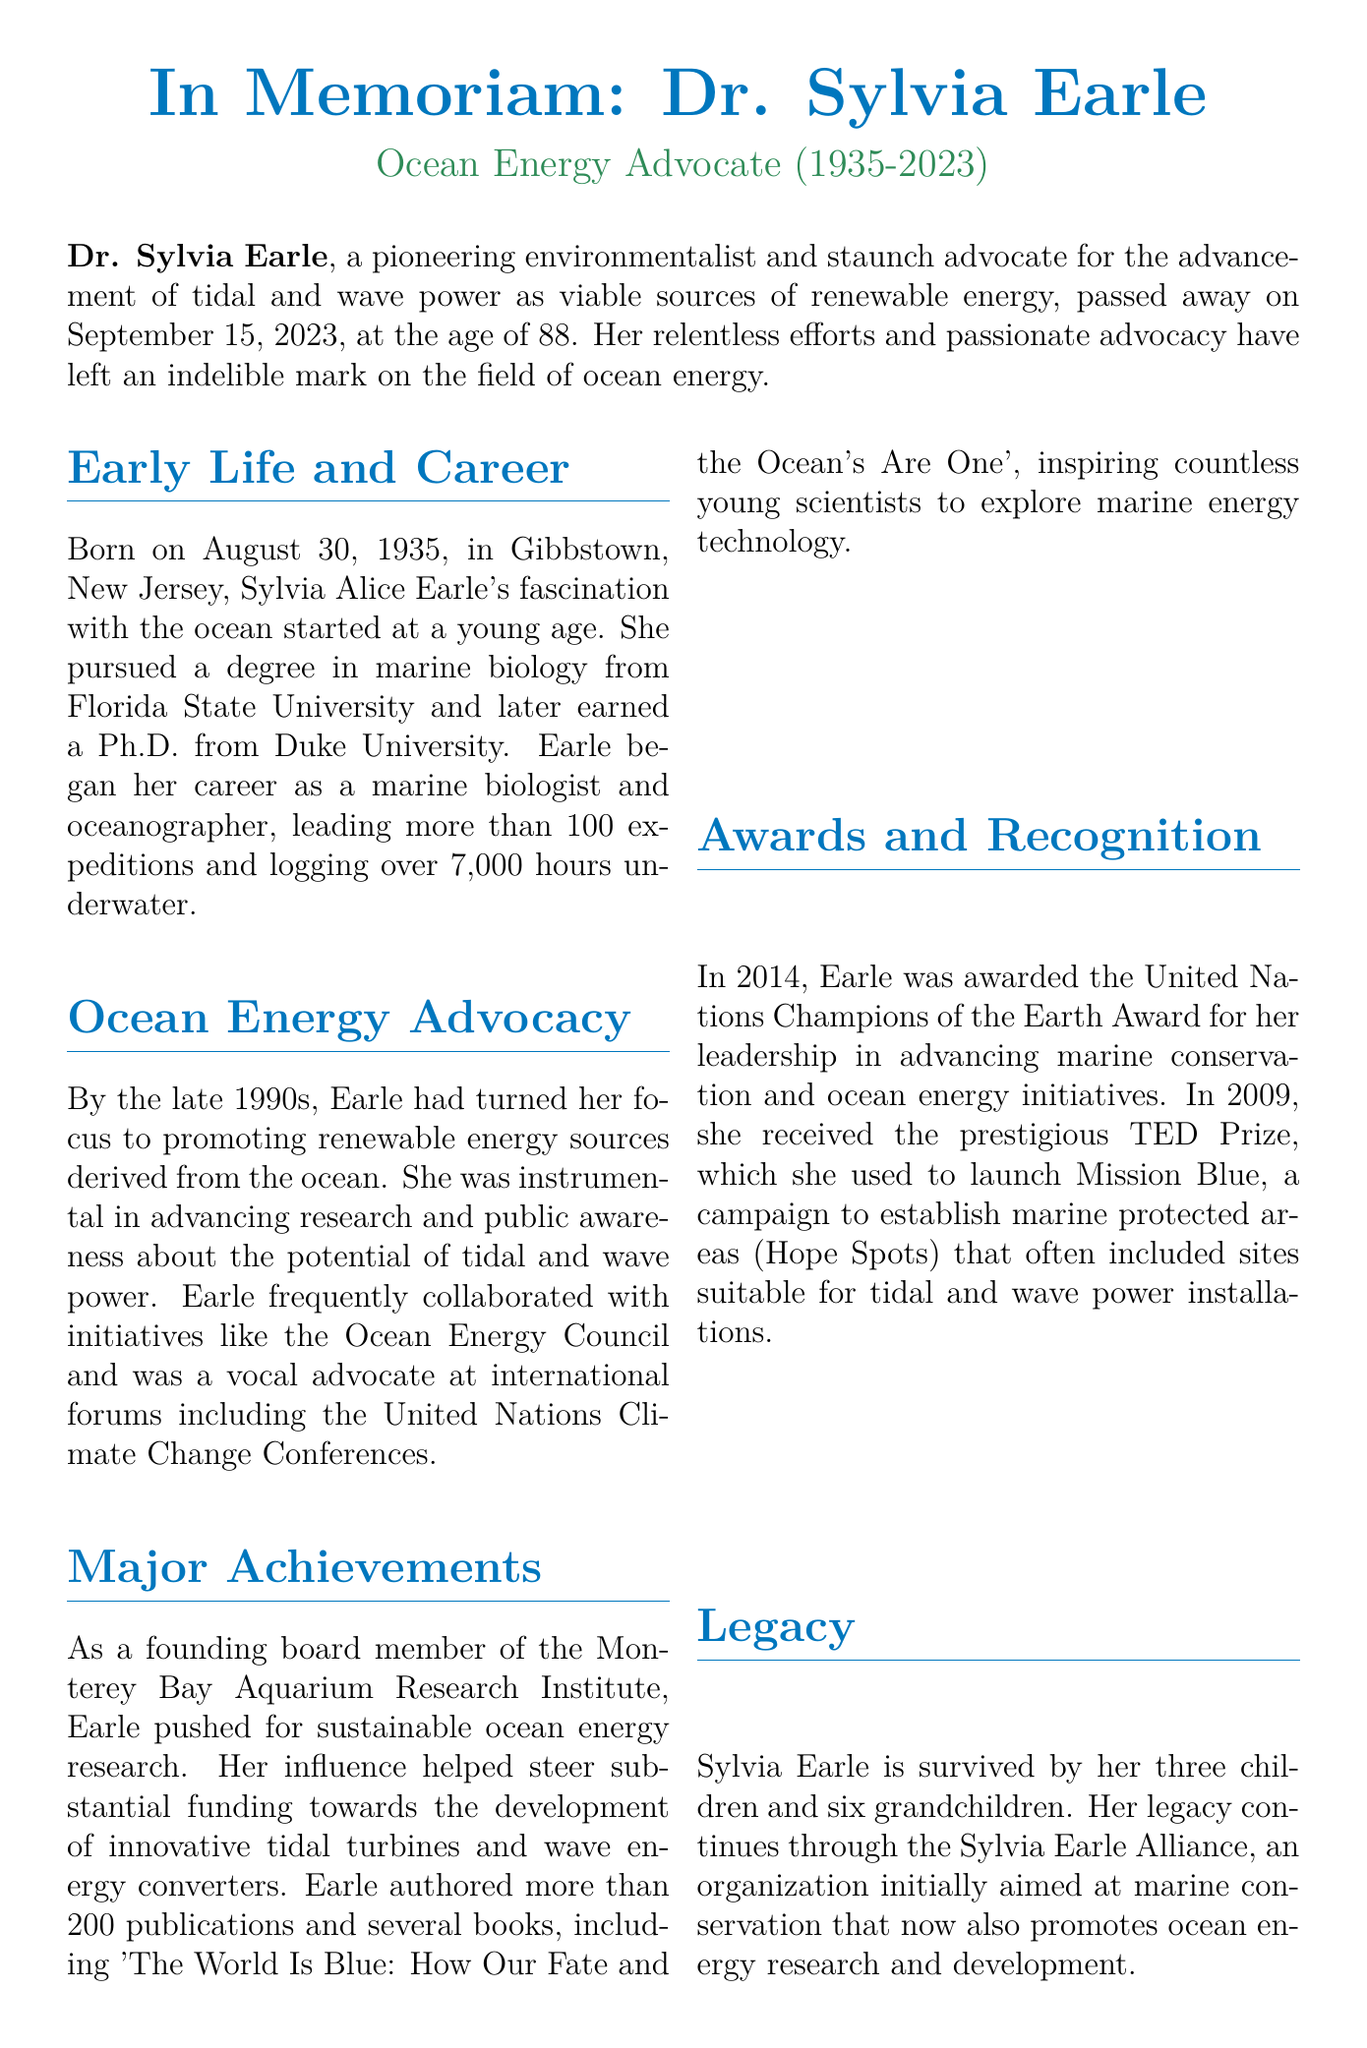what was the date of Dr. Sylvia Earle's passing? The document states that Dr. Sylvia Earle passed away on September 15, 2023.
Answer: September 15, 2023 how old was Dr. Earle at the time of her death? The document indicates that Dr. Earle was 88 years old when she passed away.
Answer: 88 which organization did Dr. Earle help to found? The document mentions that Dr. Earle was a founding board member of the Monterey Bay Aquarium Research Institute.
Answer: Monterey Bay Aquarium Research Institute what year did Dr. Earle receive the United Nations Champions of the Earth Award? The document notes that Dr. Earle received this award in 2014.
Answer: 2014 how many publications did Dr. Earle author? According to the document, Dr. Earle authored more than 200 publications.
Answer: more than 200 what was the mission of the campaign launched with the TED Prize? The document states that the campaign was to establish marine protected areas (Hope Spots).
Answer: marine protected areas (Hope Spots) what is the name of the organization that Dr. Earle's legacy continues through? The document mentions the Sylvia Earle Alliance as the organization continuing her legacy.
Answer: Sylvia Earle Alliance what was Dr. Earle's primary focus in the late 1990s? The document states that she turned her focus to promoting renewable energy sources derived from the ocean.
Answer: promoting renewable energy sources derived from the ocean how many children did Dr. Earle have? The document indicates that Dr. Earle is survived by three children.
Answer: three children 